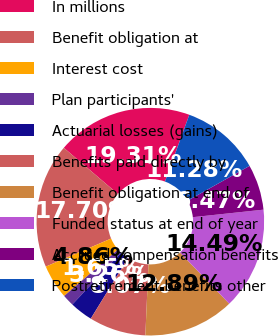Convert chart. <chart><loc_0><loc_0><loc_500><loc_500><pie_chart><fcel>In millions<fcel>Benefit obligation at<fcel>Interest cost<fcel>Plan participants'<fcel>Actuarial losses (gains)<fcel>Benefits paid directly by<fcel>Benefit obligation at end of<fcel>Funded status at end of year<fcel>Accrued compensation benefits<fcel>Postretirement benefits other<nl><fcel>19.31%<fcel>17.7%<fcel>4.86%<fcel>1.65%<fcel>3.26%<fcel>8.07%<fcel>12.89%<fcel>14.49%<fcel>6.47%<fcel>11.28%<nl></chart> 